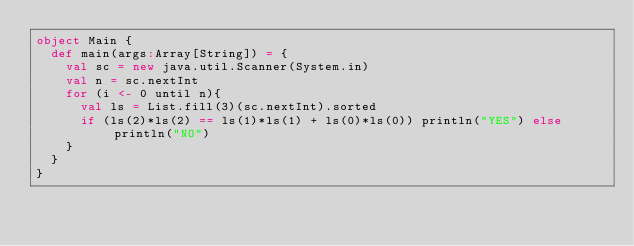<code> <loc_0><loc_0><loc_500><loc_500><_Scala_>object Main {
  def main(args:Array[String]) = {
    val sc = new java.util.Scanner(System.in)
    val n = sc.nextInt
    for (i <- 0 until n){
      val ls = List.fill(3)(sc.nextInt).sorted
      if (ls(2)*ls(2) == ls(1)*ls(1) + ls(0)*ls(0)) println("YES") else println("NO")
    }
  }
}</code> 